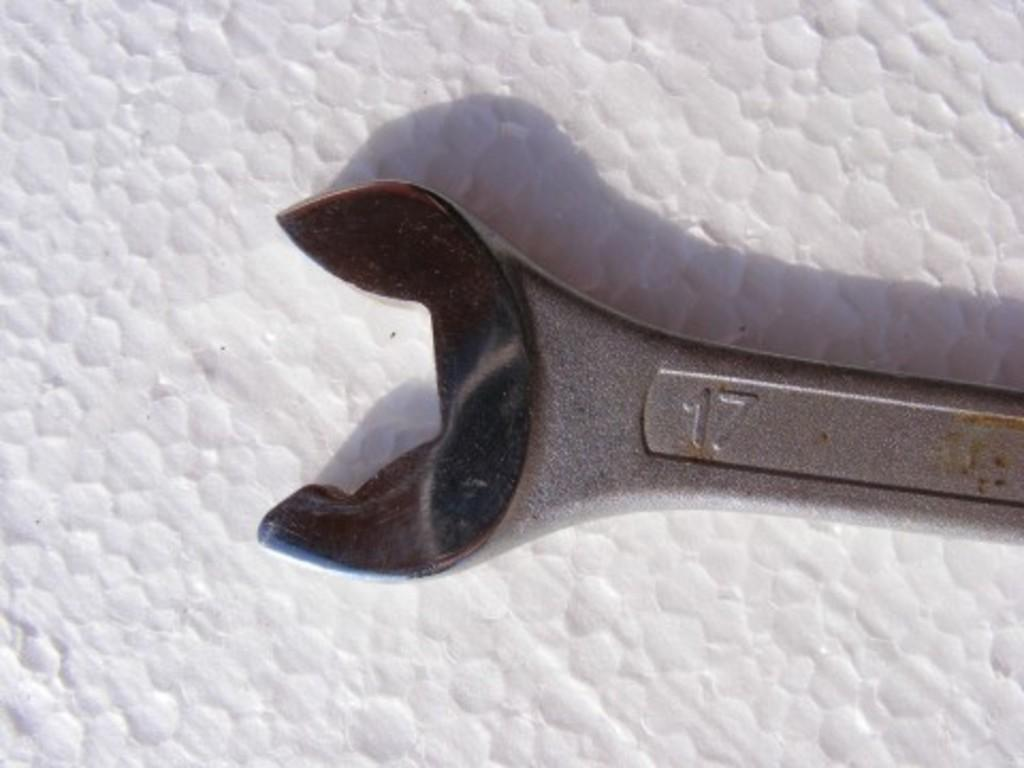What is the main object in the center of the image? There is a thermocol sheet in the center of the image. Is there anything placed on the thermocol sheet? Yes, there is an object on the thermocol sheet. How many fish can be seen swimming around the thermocol sheet? There are no fish present in the image. 